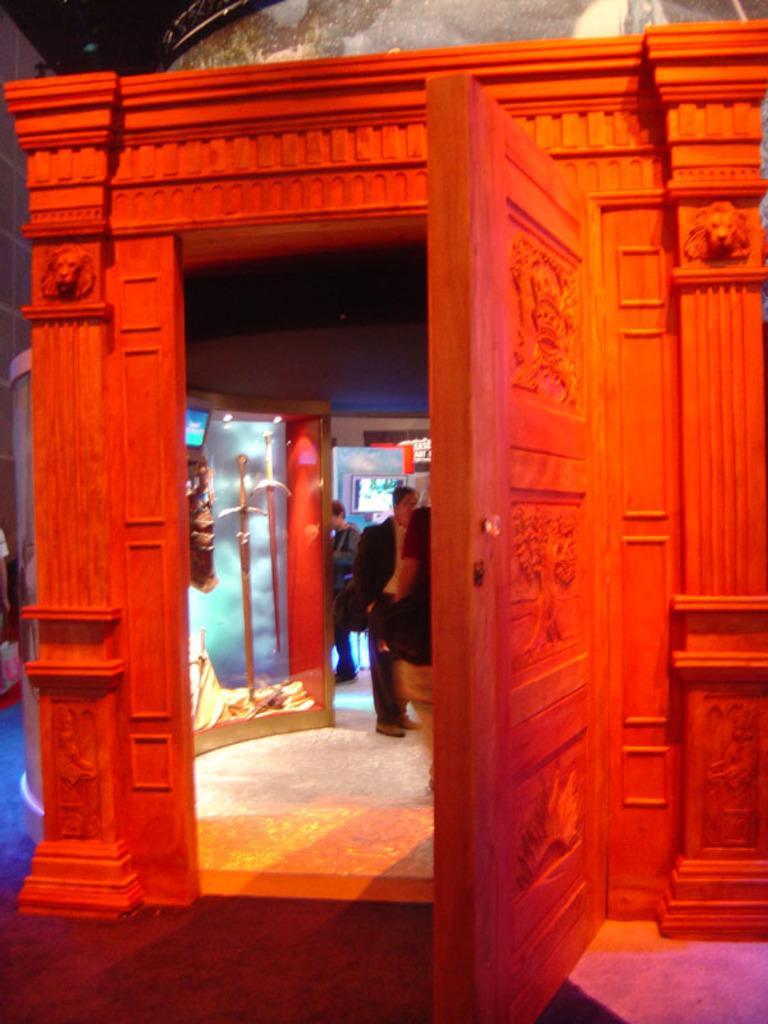Could you give a brief overview of what you see in this image? In this image we can see the entrance. In the background of the image there are some persons, pillar, wall and other objects. At the top of the image there is an object. At the bottom of the object there is the floor. 